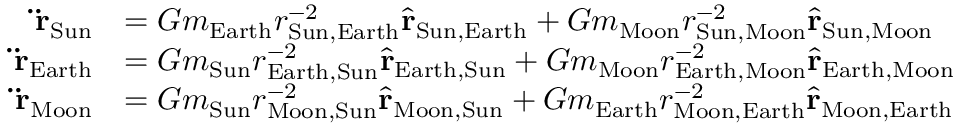Convert formula to latex. <formula><loc_0><loc_0><loc_500><loc_500>{ \begin{array} { r l } { \ddot { r } _ { S u n } } & { = G m _ { E a r t h } r _ { { S u n } , { E a r t h } } ^ { - 2 } { \hat { r } } _ { { S u n } , { E a r t h } } + G m _ { M o o n } r _ { { S u n } , { M o o n } } ^ { - 2 } { \hat { r } } _ { { S u n } , { M o o n } } } \\ { \ddot { r } _ { E a r t h } } & { = G m _ { S u n } r _ { { E a r t h } , { S u n } } ^ { - 2 } { \hat { r } } _ { { E a r t h } , { S u n } } + G m _ { M o o n } r _ { { E a r t h } , { M o o n } } ^ { - 2 } { \hat { r } } _ { { E a r t h } , { M o o n } } } \\ { \ddot { r } _ { M o o n } } & { = G m _ { S u n } r _ { { M o o n } , { S u n } } ^ { - 2 } { \hat { r } } _ { { M o o n } , { S u n } } + G m _ { E a r t h } r _ { { M o o n } , { E a r t h } } ^ { - 2 } { \hat { r } } _ { { M o o n } , { E a r t h } } } \end{array} }</formula> 